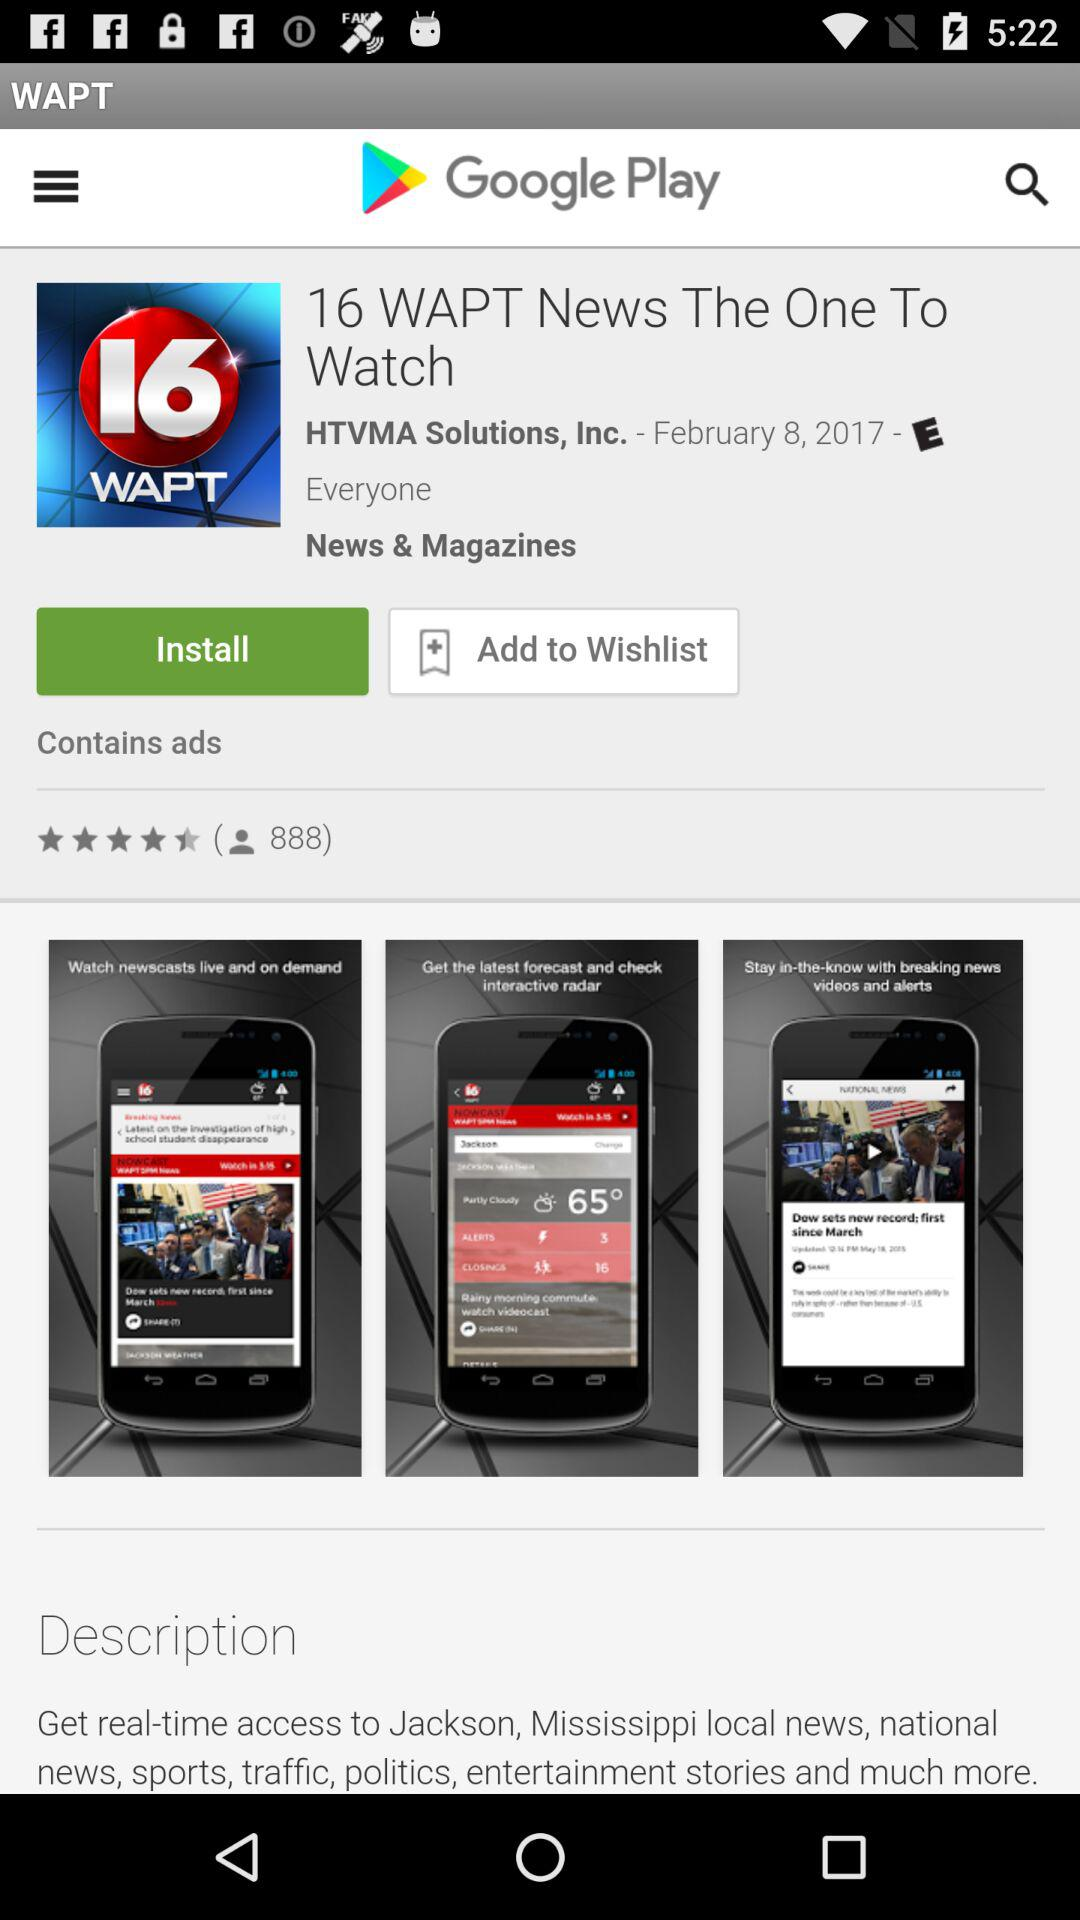What's the type of application? The type is "News & Magazines". 